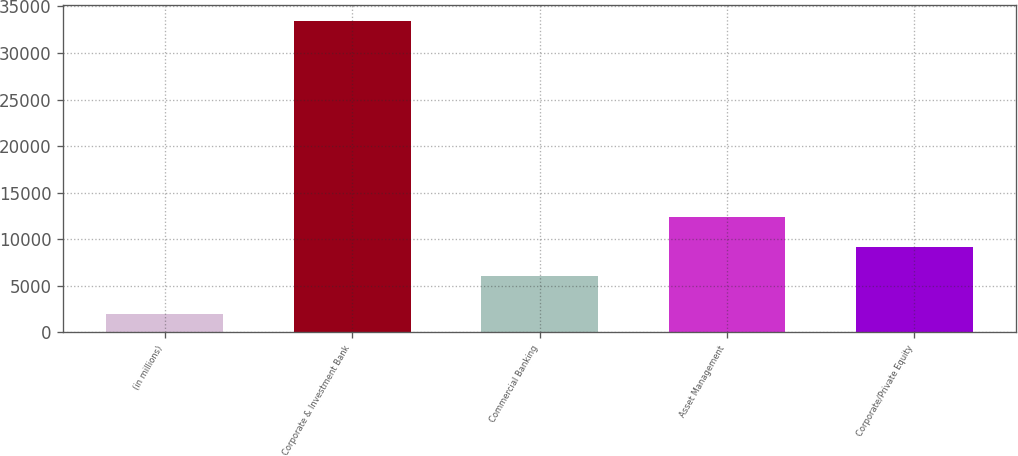<chart> <loc_0><loc_0><loc_500><loc_500><bar_chart><fcel>(in millions)<fcel>Corporate & Investment Bank<fcel>Commercial Banking<fcel>Asset Management<fcel>Corporate/Private Equity<nl><fcel>2010<fcel>33477<fcel>6040<fcel>12333.4<fcel>9186.7<nl></chart> 